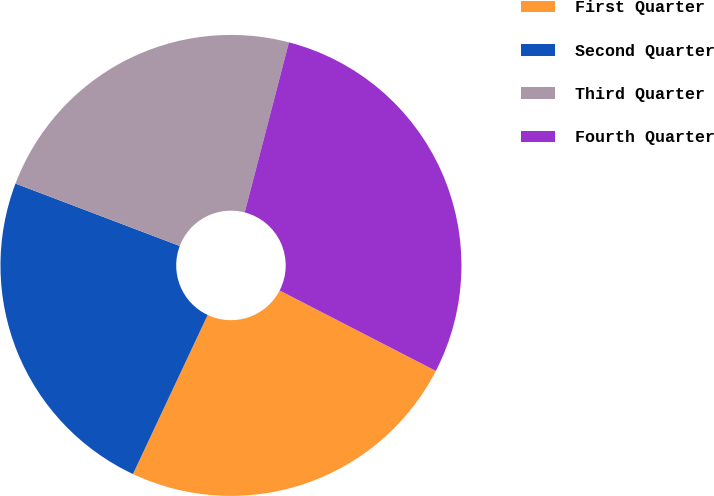<chart> <loc_0><loc_0><loc_500><loc_500><pie_chart><fcel>First Quarter<fcel>Second Quarter<fcel>Third Quarter<fcel>Fourth Quarter<nl><fcel>24.42%<fcel>23.79%<fcel>23.27%<fcel>28.52%<nl></chart> 